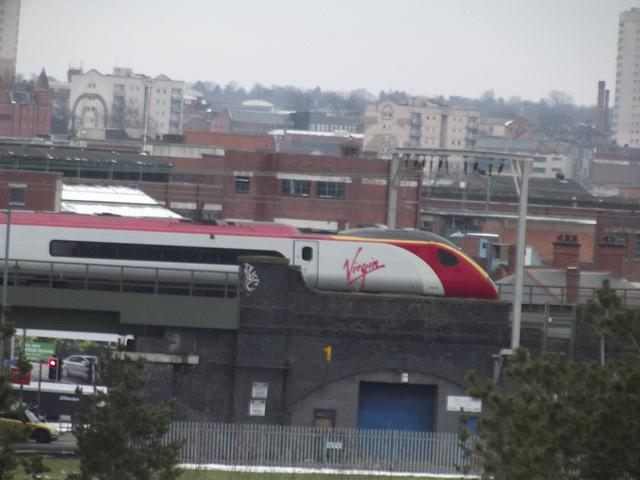The owners of this company first started it in which business? music 